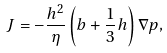Convert formula to latex. <formula><loc_0><loc_0><loc_500><loc_500>J = - \frac { h ^ { 2 } } { \eta } \left ( b + \frac { 1 } { 3 } h \right ) \nabla p ,</formula> 